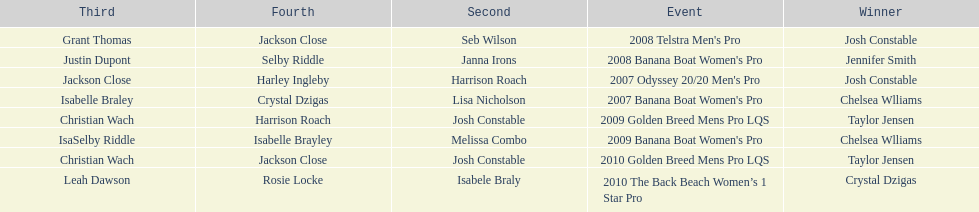What is the total number of times chelsea williams was the winner between 2007 and 2010? 2. 